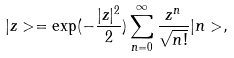Convert formula to latex. <formula><loc_0><loc_0><loc_500><loc_500>| z > = \exp ( - \frac { | z | ^ { 2 } } { 2 } ) \sum ^ { \infty } _ { n = 0 } \frac { z ^ { n } } { \sqrt { n ! } } | n > ,</formula> 